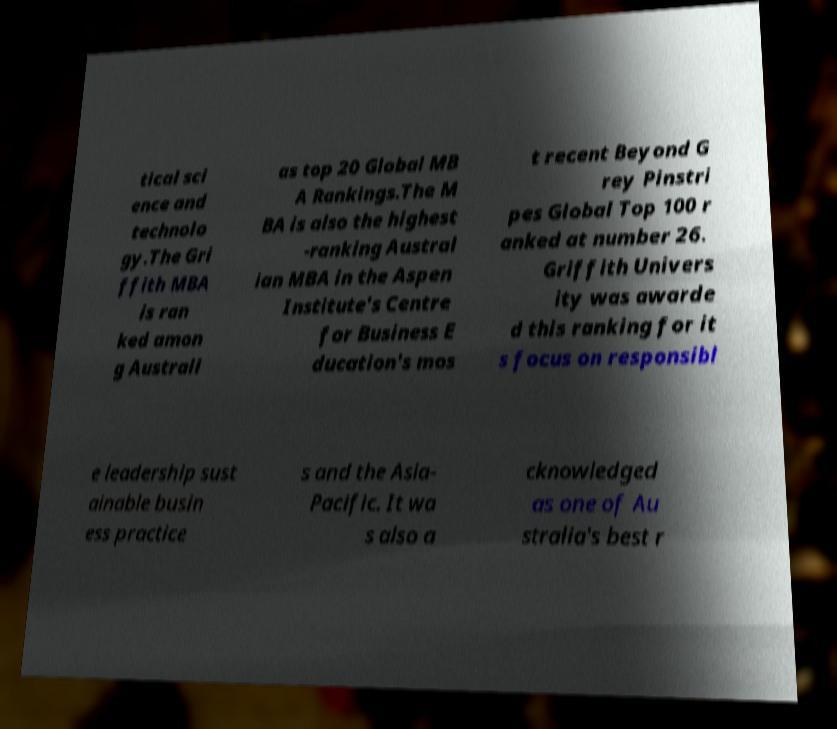Please identify and transcribe the text found in this image. tical sci ence and technolo gy.The Gri ffith MBA is ran ked amon g Australi as top 20 Global MB A Rankings.The M BA is also the highest -ranking Austral ian MBA in the Aspen Institute's Centre for Business E ducation's mos t recent Beyond G rey Pinstri pes Global Top 100 r anked at number 26. Griffith Univers ity was awarde d this ranking for it s focus on responsibl e leadership sust ainable busin ess practice s and the Asia- Pacific. It wa s also a cknowledged as one of Au stralia's best r 